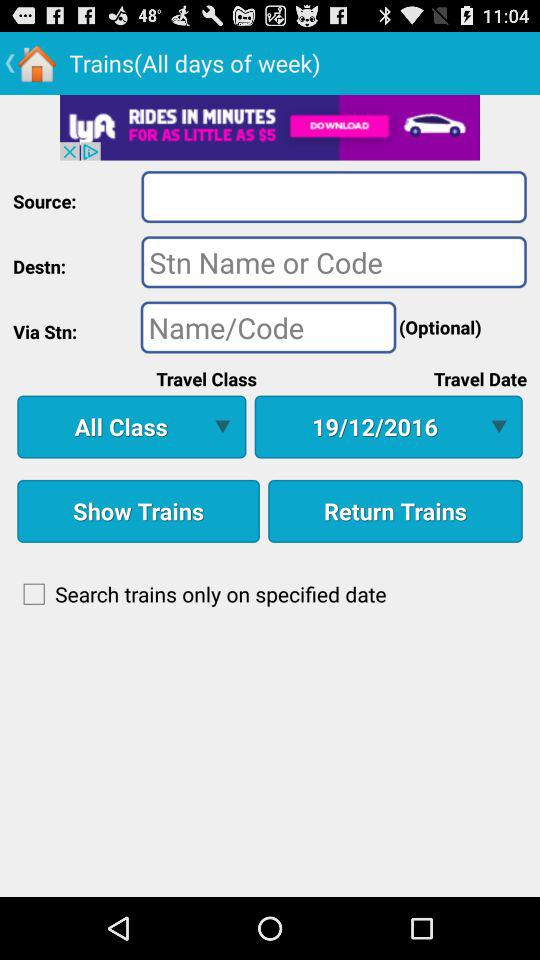What's the travel date? The travel date is December 19, 2016. 